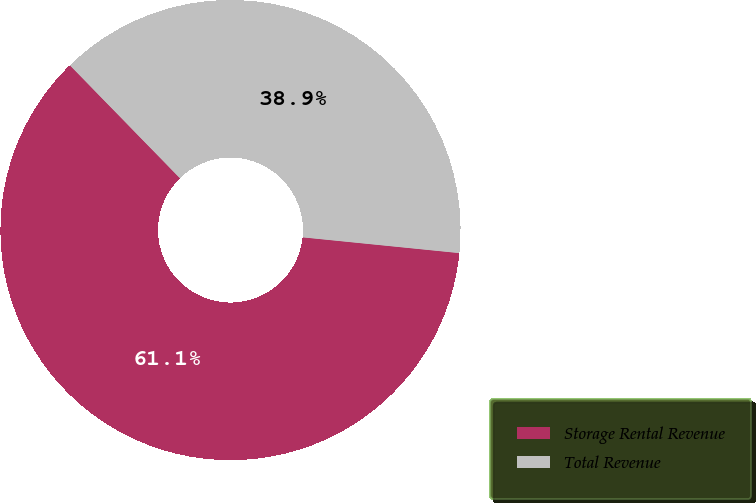Convert chart to OTSL. <chart><loc_0><loc_0><loc_500><loc_500><pie_chart><fcel>Storage Rental Revenue<fcel>Total Revenue<nl><fcel>61.11%<fcel>38.89%<nl></chart> 